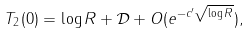<formula> <loc_0><loc_0><loc_500><loc_500>T _ { 2 } ( 0 ) = \log R + \mathcal { D } + O ( e ^ { - c ^ { \prime } \sqrt { \log R } } ) ,</formula> 